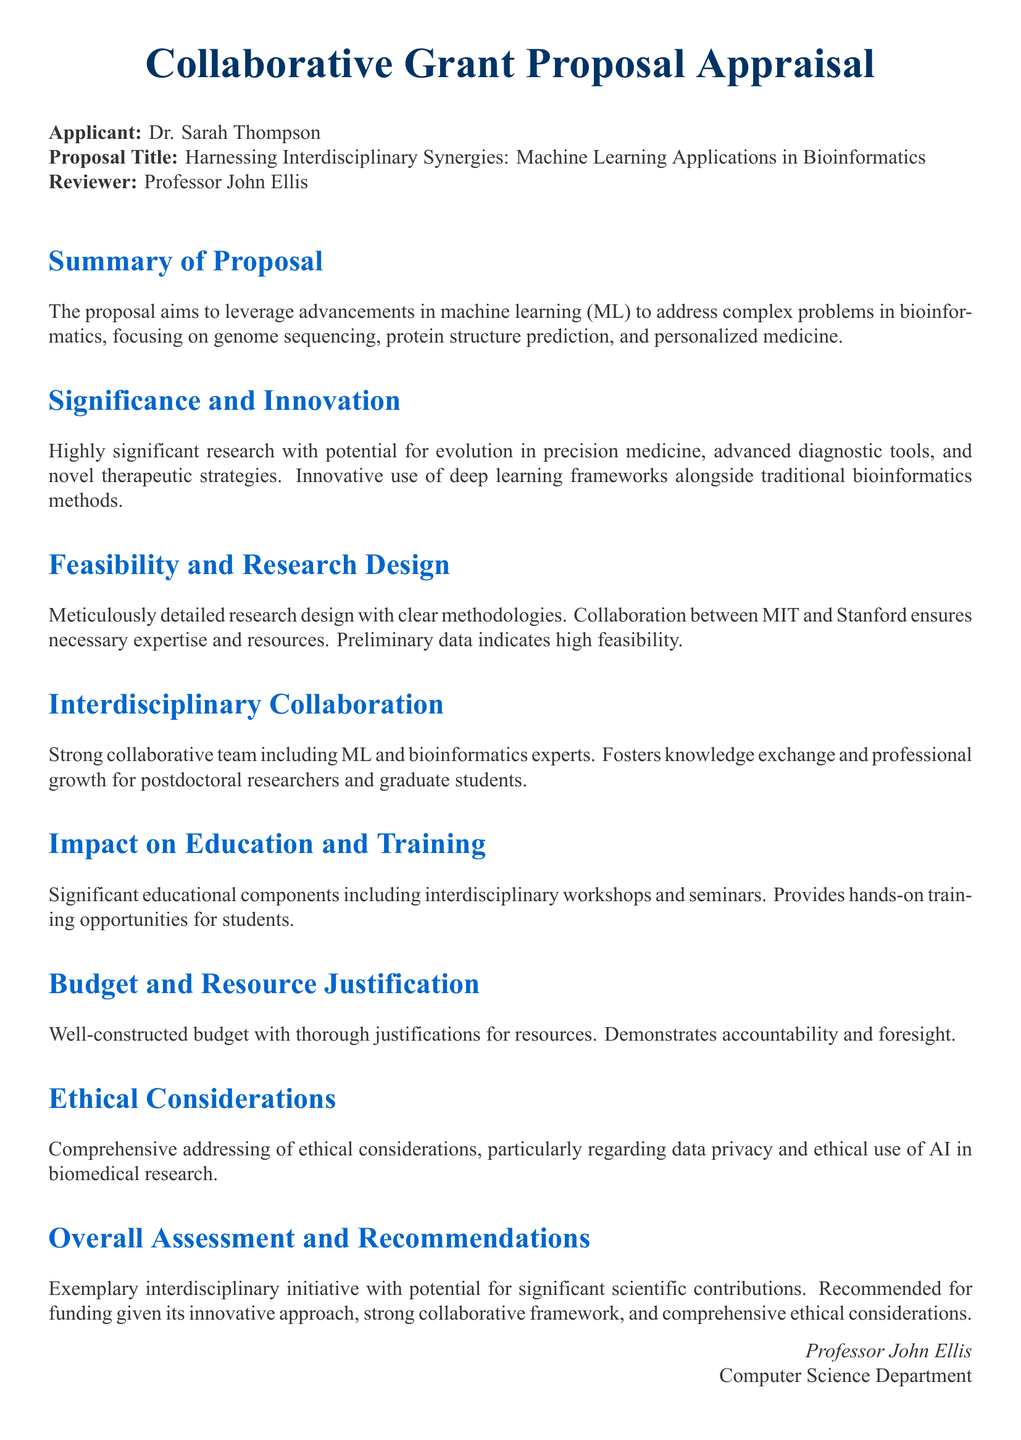What is the proposal title? The proposal title can be found in the document under the section detailing the applicant's information.
Answer: Harnessing Interdisciplinary Synergies: Machine Learning Applications in Bioinformatics Who is the applicant? The name of the applicant is specified near the beginning of the document.
Answer: Dr. Sarah Thompson What institutions are involved in the collaboration? The involved institutions were mentioned in the section discussing the feasibility and research design.
Answer: MIT and Stanford What is emphasized in the significance and innovation section? The significance and innovation section outlines the potential impact of the research.
Answer: Evolution in precision medicine How is the budget characterized? The budget is described in a specific section dedicated to resource justification.
Answer: Well-constructed What is the overall assessment recommendation? The overall assessment provides insight into the reviewer's recommendation for the proposal.
Answer: Recommended for funding What aspect of ethical considerations is addressed? The ethical considerations section discusses important topics related to the use of data and AI.
Answer: Data privacy What type of educational components does the proposal include? The section on impact on education and training highlights specific components of the educational plan.
Answer: Interdisciplinary workshops and seminars 